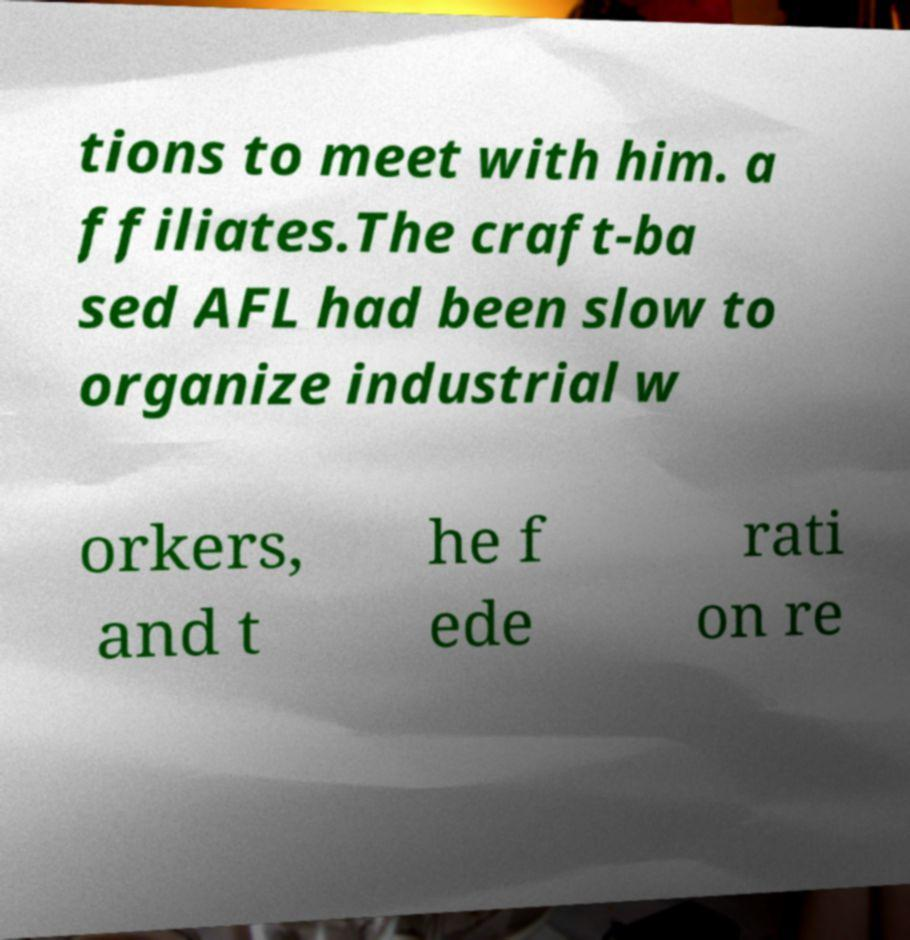There's text embedded in this image that I need extracted. Can you transcribe it verbatim? tions to meet with him. a ffiliates.The craft-ba sed AFL had been slow to organize industrial w orkers, and t he f ede rati on re 